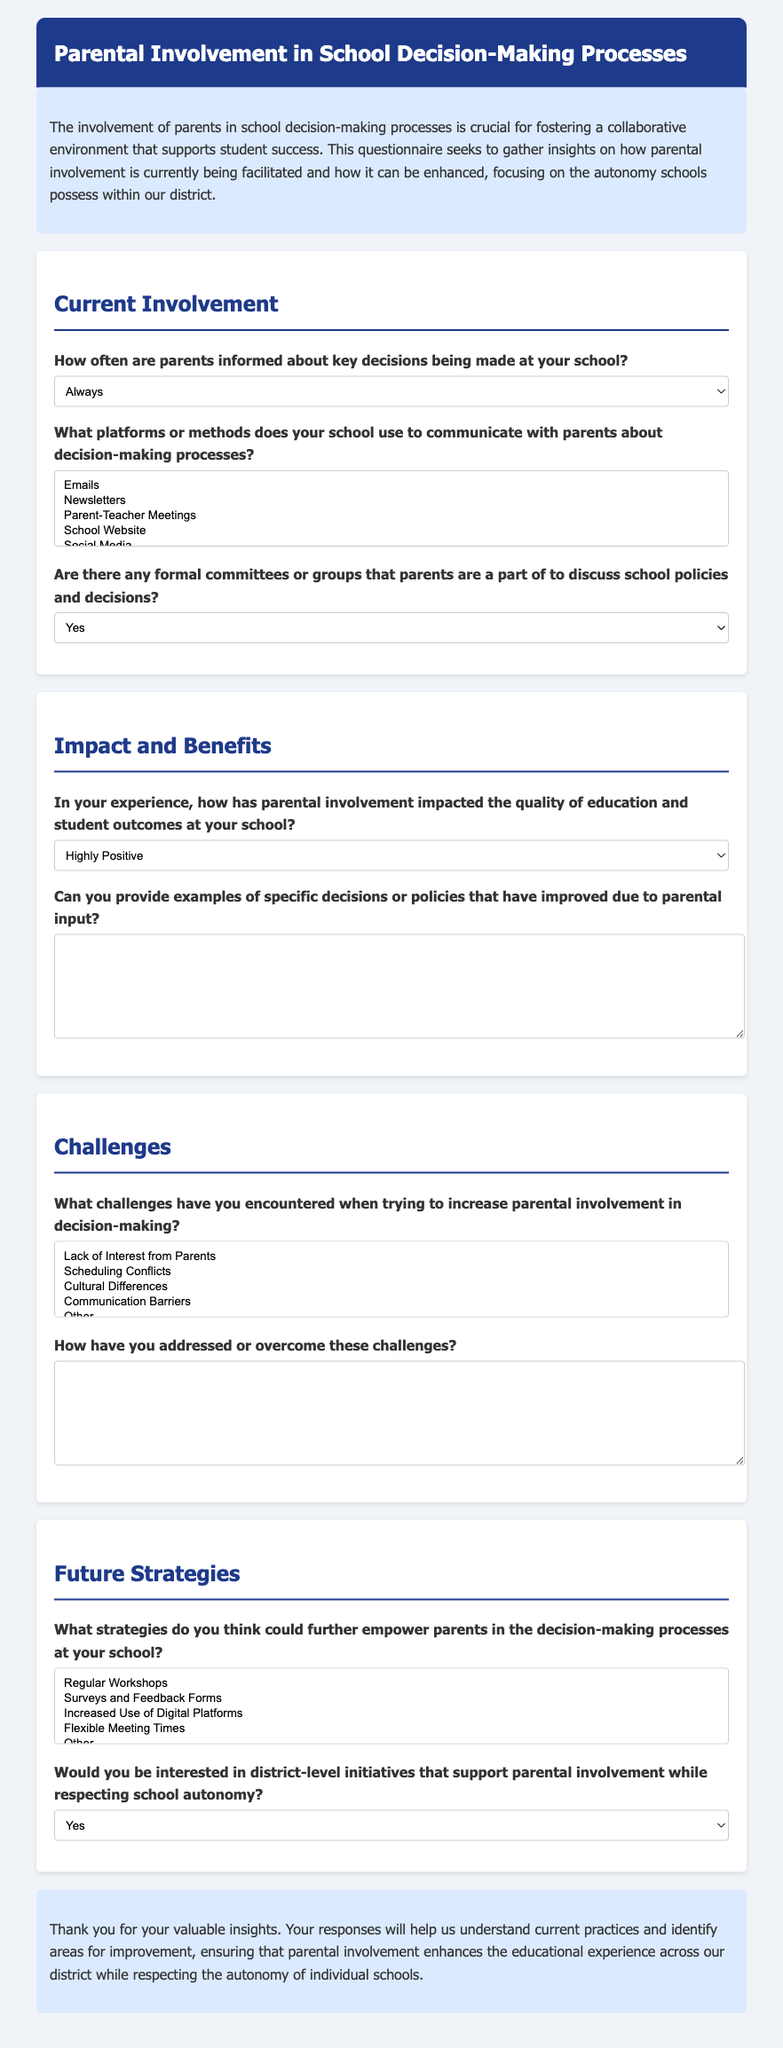how many sections are there in the questionnaire? The questionnaire is divided into five sections: Current Involvement, Impact and Benefits, Challenges, Future Strategies, and an introduction and conclusion.
Answer: 5 what is the title of the questionnaire? The title of the questionnaire as shown in the header section is "Parental Involvement in School Decision-Making Processes."
Answer: Parental Involvement in School Decision-Making Processes what is the highest option for how often parents are informed about key decisions? This option can be found in the section titled "Current Involvement," where options for parental information frequency are provided.
Answer: Always what types of communication methods are listed for informing parents? The "Current Involvement" section contains a multiple-choice question outlining various communication methods.
Answer: Emails, Newsletters, Parent-Teacher Meetings, School Website, Social Media what is the response option for whether parents are part of formal committees? This question is found in the "Current Involvement" section, specifically regarding the participation of parents in formal discussions.
Answer: Yes how does the questionnaire assess the impact of parental involvement? The questionnaire contains a section focused on the effects of parental involvement, specifically asking about its effects on education and student outcomes.
Answer: Highly Positive, Positive, Neutral, Negative, Highly Negative what suggestions are provided for empowering parents further? In the "Future Strategies" section, various strategies for enhancing parental involvement are presented in a multiple-choice format.
Answer: Regular Workshops, Surveys and Feedback Forms, Increased Use of Digital Platforms, Flexible Meeting Times is there an option for district-level initiatives supporting parental involvement? The questionnaire explicitly includes a question about interest in district-level initiatives that respect school autonomy.
Answer: Yes what is the visual style of the document's header? The document has specific styling details such as background color and text color which enhance its visual appeal.
Answer: Dark blue background, white text 